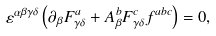Convert formula to latex. <formula><loc_0><loc_0><loc_500><loc_500>\varepsilon ^ { \alpha \beta \gamma \delta } \left ( \partial _ { \beta } F ^ { a } _ { \gamma \delta } + A ^ { b } _ { \beta } F ^ { c } _ { \gamma \delta } f ^ { a b c } \right ) = 0 ,</formula> 